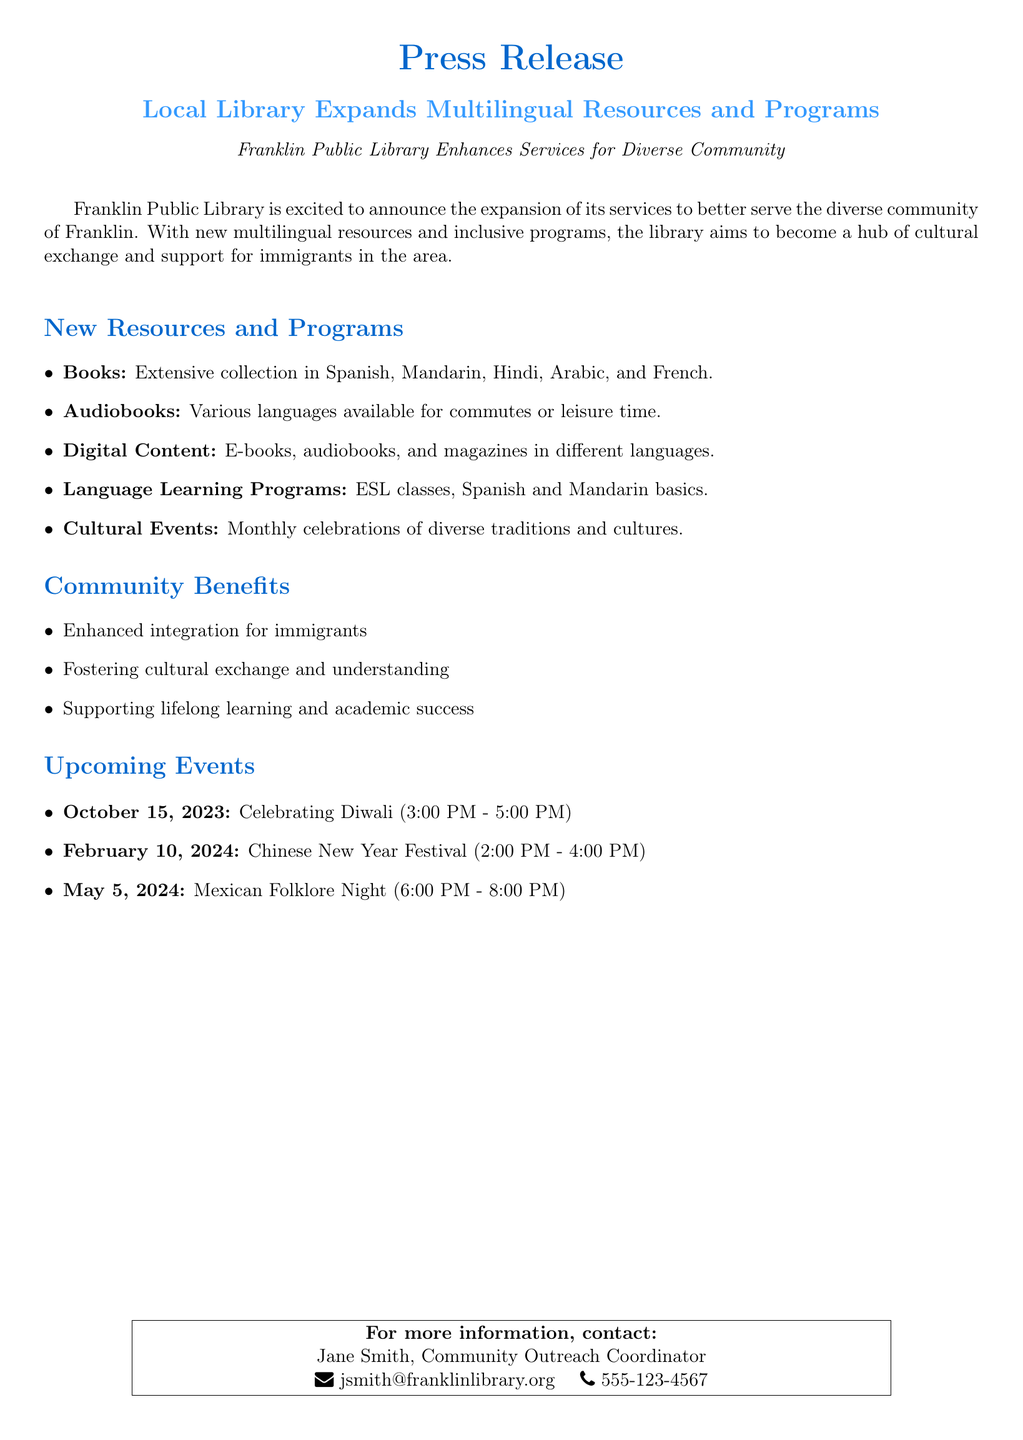What is the name of the library? The document mentions that the library's name is Franklin Public Library.
Answer: Franklin Public Library What new languages are included in the book collection? The document lists the languages included in the extensive collection of books such as Spanish, Mandarin, Hindi, Arabic, and French.
Answer: Spanish, Mandarin, Hindi, Arabic, French When is the Diwali celebration scheduled? The document provides a specific date and time for the Diwali celebration on October 15, 2023, from 3:00 PM to 5:00 PM.
Answer: October 15, 2023 What types of programs are offered for language learning? The document specifies the language learning programs available, which include ESL classes and Spanish and Mandarin basics.
Answer: ESL classes, Spanish and Mandarin basics What is one benefit mentioned for the immigrant community? The document highlights several benefits for the immigrant community, one of which is enhanced integration for immigrants.
Answer: Enhanced integration for immigrants What type of document is this? The structure and content clearly indicate that this is a press release announcing new library services.
Answer: Press Release How many cultural events are listed in the document? The document enumerates three cultural events that will take place.
Answer: Three 